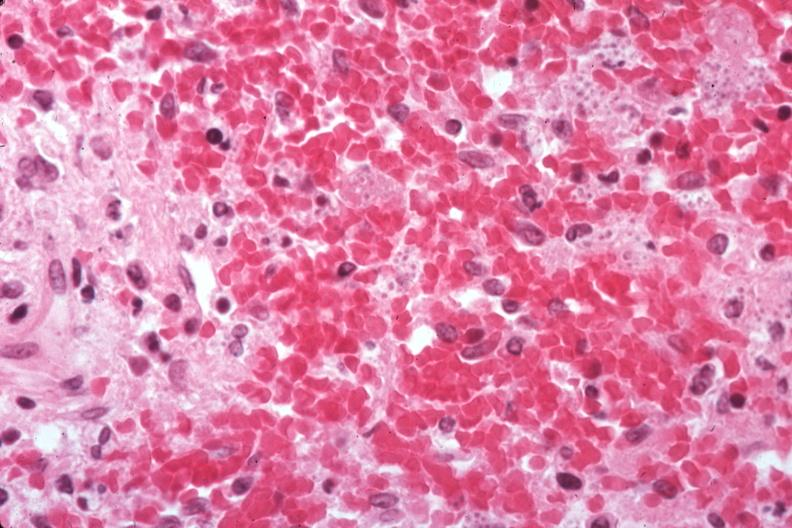s cranial artery present?
Answer the question using a single word or phrase. No 